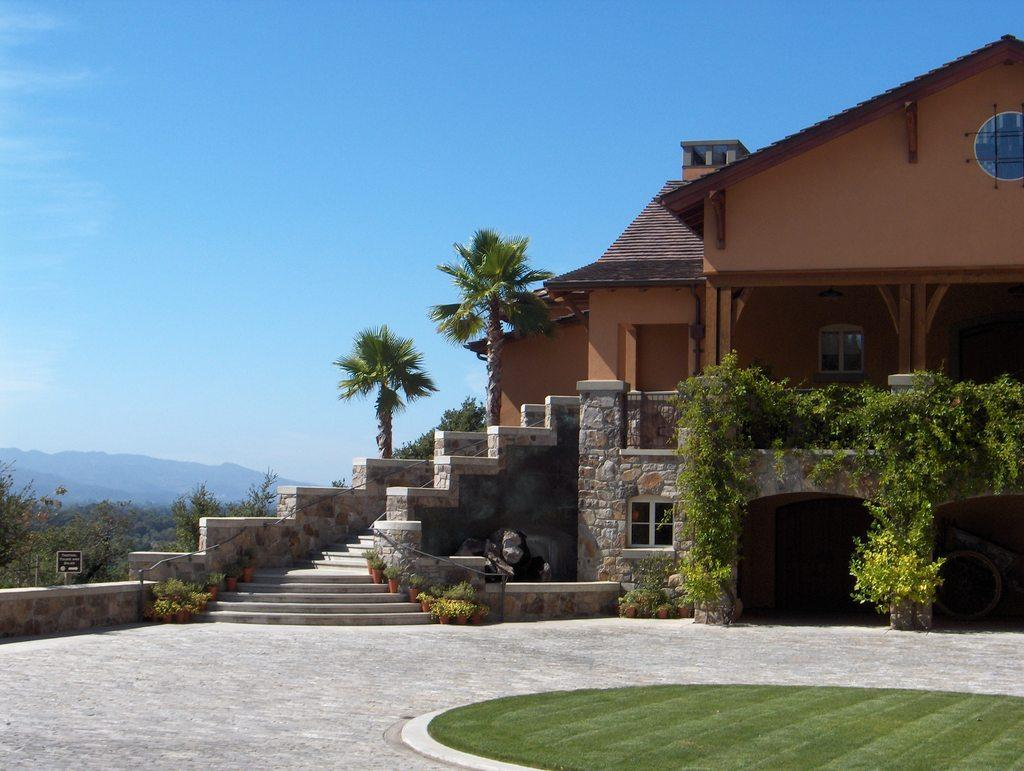What type of ground surface is visible in the image? There is grass on the ground in the image. What can be seen in the distance behind the grass? There is a building, houseplants, a board, trees, mountains, and the sky visible in the background of the image. What type of wood is the goose using to wash its feathers in the image? There is no goose present in the image, and therefore no such activity can be observed. 